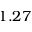Convert formula to latex. <formula><loc_0><loc_0><loc_500><loc_500>1 . 2 7</formula> 